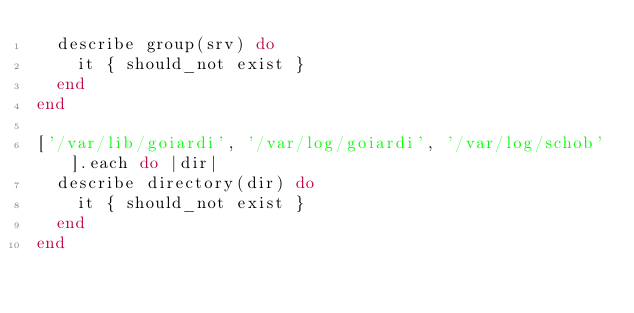<code> <loc_0><loc_0><loc_500><loc_500><_Ruby_>  describe group(srv) do
    it { should_not exist }
  end
end

['/var/lib/goiardi', '/var/log/goiardi', '/var/log/schob'].each do |dir|
  describe directory(dir) do
    it { should_not exist }
  end
end
</code> 